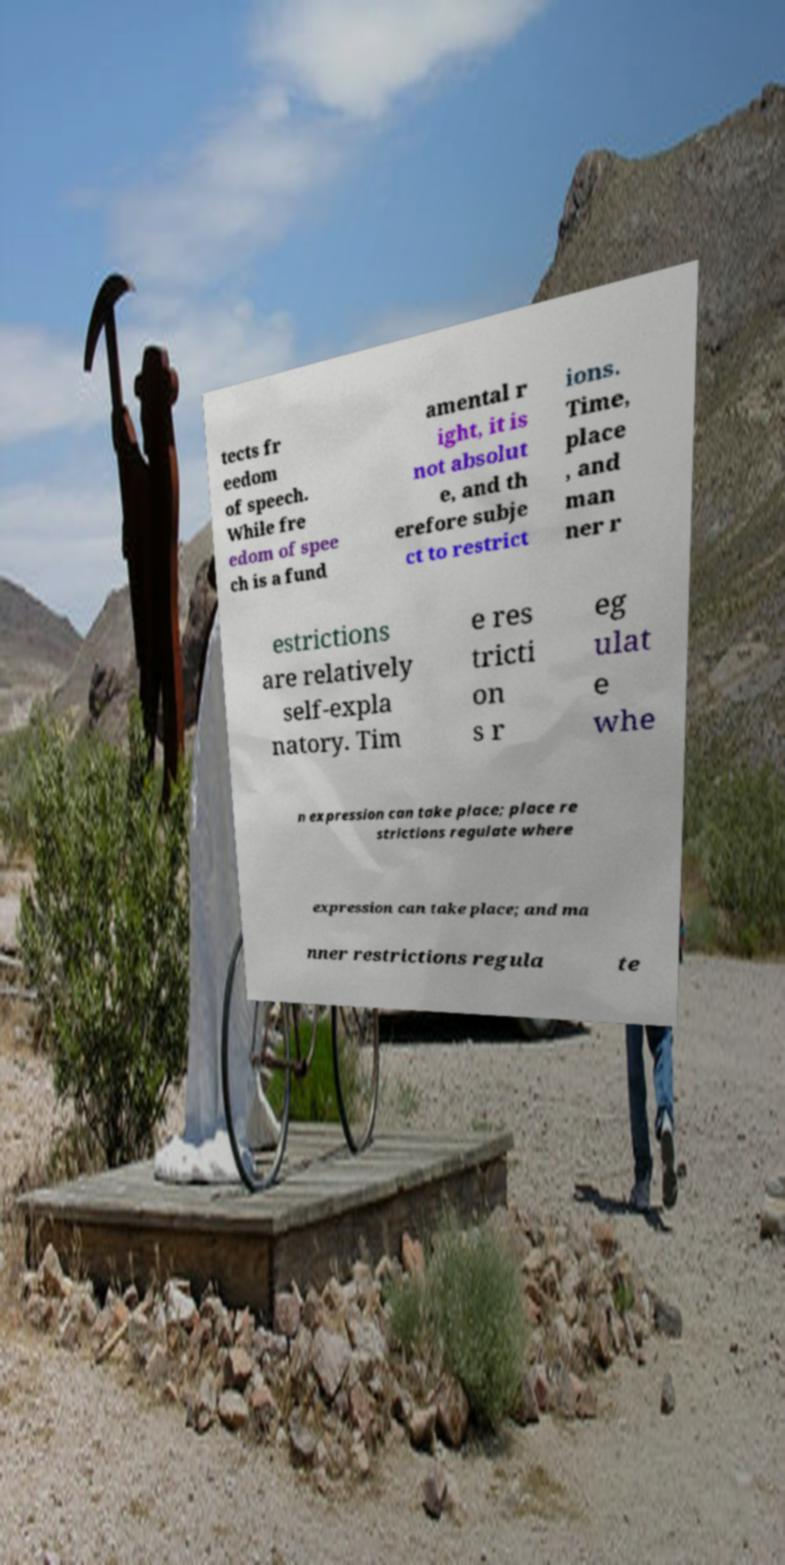Could you extract and type out the text from this image? tects fr eedom of speech. While fre edom of spee ch is a fund amental r ight, it is not absolut e, and th erefore subje ct to restrict ions. Time, place , and man ner r estrictions are relatively self-expla natory. Tim e res tricti on s r eg ulat e whe n expression can take place; place re strictions regulate where expression can take place; and ma nner restrictions regula te 